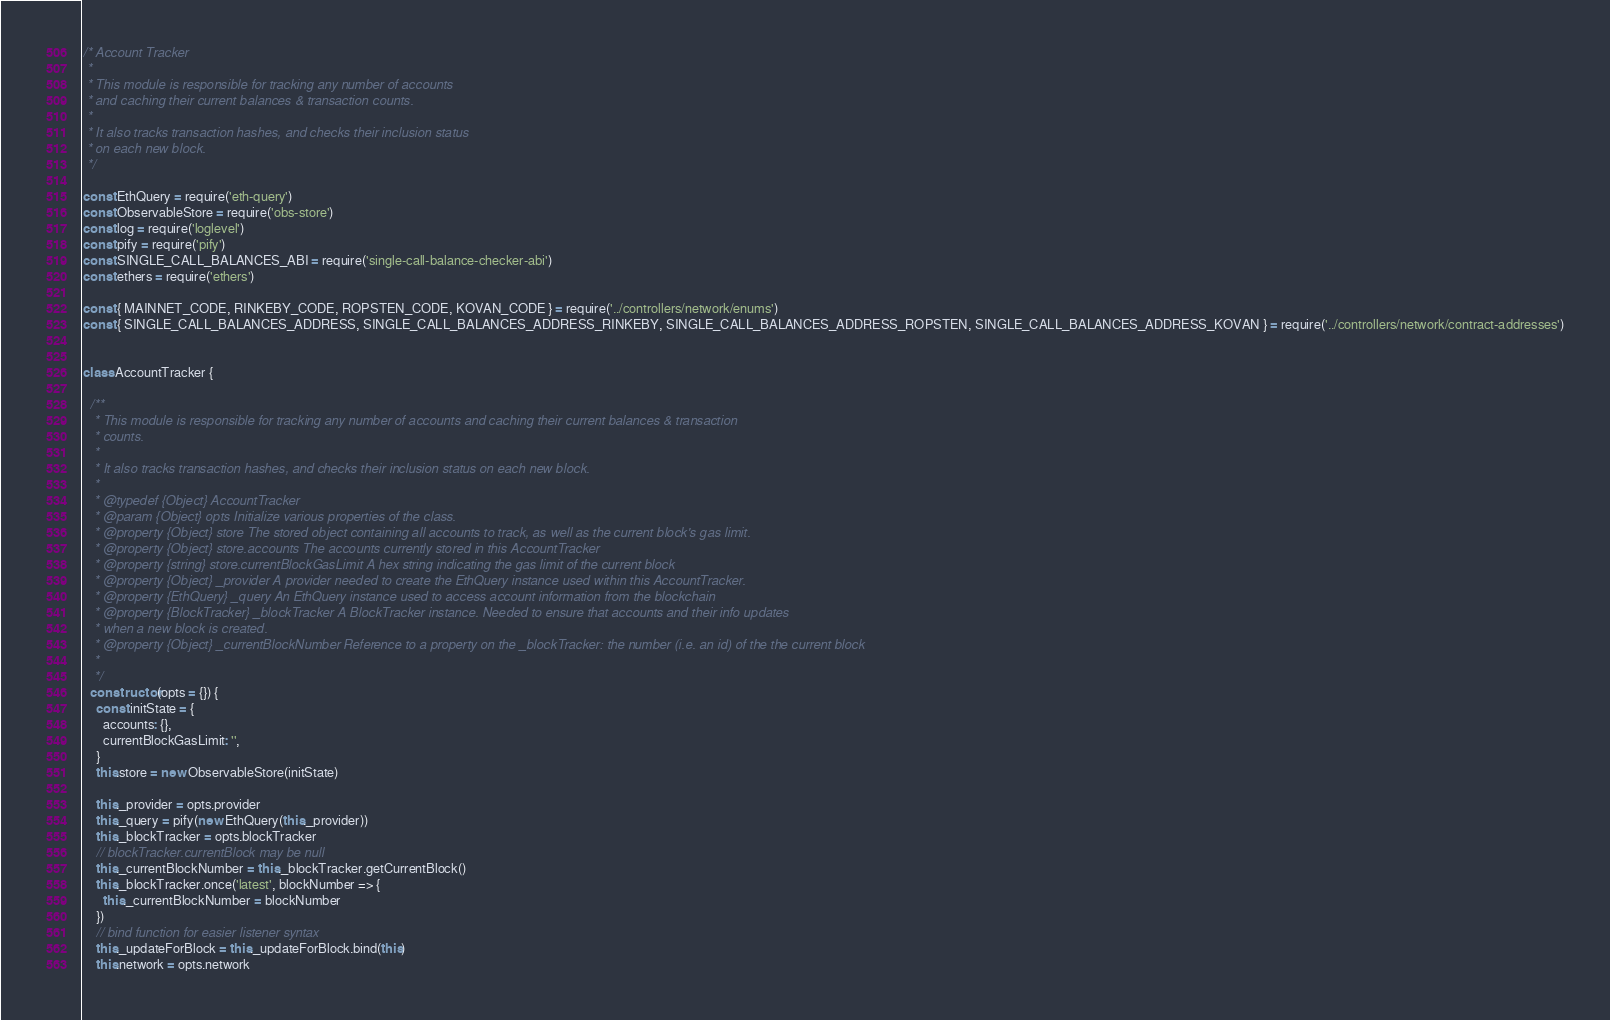<code> <loc_0><loc_0><loc_500><loc_500><_JavaScript_>/* Account Tracker
 *
 * This module is responsible for tracking any number of accounts
 * and caching their current balances & transaction counts.
 *
 * It also tracks transaction hashes, and checks their inclusion status
 * on each new block.
 */

const EthQuery = require('eth-query')
const ObservableStore = require('obs-store')
const log = require('loglevel')
const pify = require('pify')
const SINGLE_CALL_BALANCES_ABI = require('single-call-balance-checker-abi')
const ethers = require('ethers')

const { MAINNET_CODE, RINKEBY_CODE, ROPSTEN_CODE, KOVAN_CODE } = require('../controllers/network/enums')
const { SINGLE_CALL_BALANCES_ADDRESS, SINGLE_CALL_BALANCES_ADDRESS_RINKEBY, SINGLE_CALL_BALANCES_ADDRESS_ROPSTEN, SINGLE_CALL_BALANCES_ADDRESS_KOVAN } = require('../controllers/network/contract-addresses')


class AccountTracker {

  /**
   * This module is responsible for tracking any number of accounts and caching their current balances & transaction
   * counts.
   *
   * It also tracks transaction hashes, and checks their inclusion status on each new block.
   *
   * @typedef {Object} AccountTracker
   * @param {Object} opts Initialize various properties of the class.
   * @property {Object} store The stored object containing all accounts to track, as well as the current block's gas limit.
   * @property {Object} store.accounts The accounts currently stored in this AccountTracker
   * @property {string} store.currentBlockGasLimit A hex string indicating the gas limit of the current block
   * @property {Object} _provider A provider needed to create the EthQuery instance used within this AccountTracker.
   * @property {EthQuery} _query An EthQuery instance used to access account information from the blockchain
   * @property {BlockTracker} _blockTracker A BlockTracker instance. Needed to ensure that accounts and their info updates
   * when a new block is created.
   * @property {Object} _currentBlockNumber Reference to a property on the _blockTracker: the number (i.e. an id) of the the current block
   *
   */
  constructor (opts = {}) {
    const initState = {
      accounts: {},
      currentBlockGasLimit: '',
    }
    this.store = new ObservableStore(initState)

    this._provider = opts.provider
    this._query = pify(new EthQuery(this._provider))
    this._blockTracker = opts.blockTracker
    // blockTracker.currentBlock may be null
    this._currentBlockNumber = this._blockTracker.getCurrentBlock()
    this._blockTracker.once('latest', blockNumber => {
      this._currentBlockNumber = blockNumber
    })
    // bind function for easier listener syntax
    this._updateForBlock = this._updateForBlock.bind(this)
    this.network = opts.network
</code> 